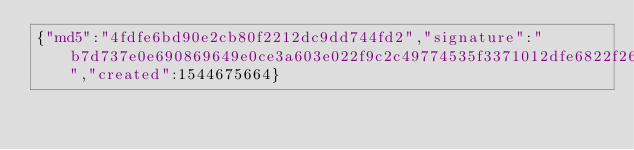Convert code to text. <code><loc_0><loc_0><loc_500><loc_500><_SML_>{"md5":"4fdfe6bd90e2cb80f2212dc9dd744fd2","signature":"b7d737e0e690869649e0ce3a603e022f9c2c49774535f3371012dfe6822f26682d9bd37b695690c0328f73fe858f3b96cf31249d009bd97f62a7537de2481601","created":1544675664}</code> 